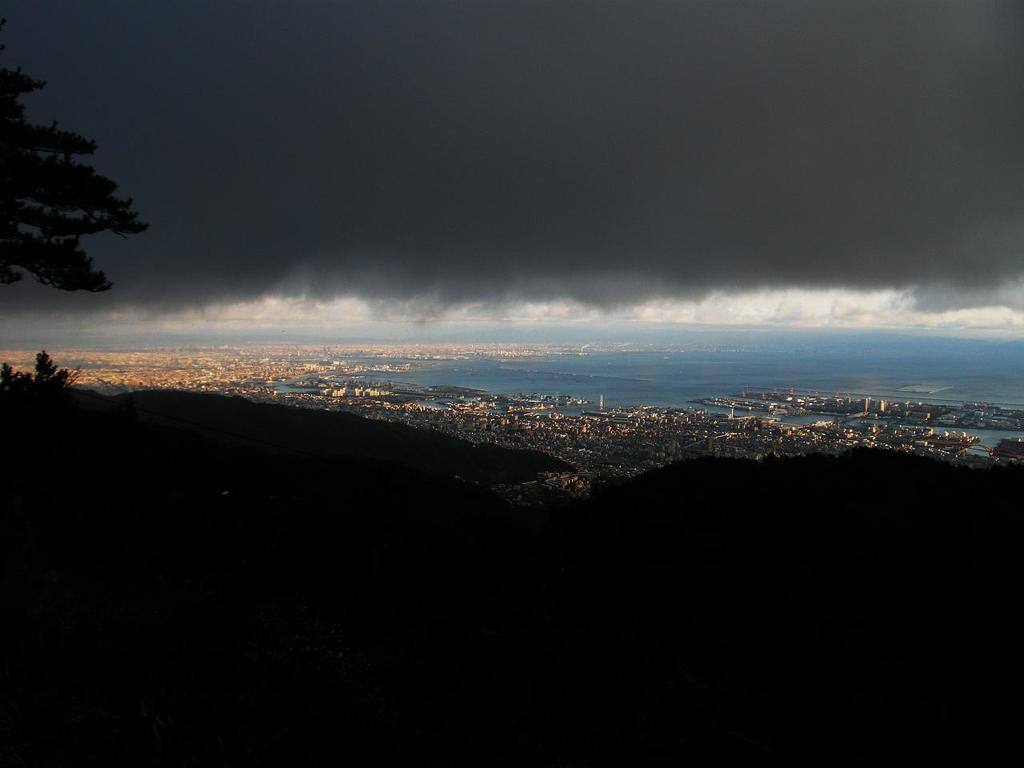What can be seen in the sky in the image? The sky is visible in the image, and clouds are present. What type of natural feature can be seen in the image? There is water visible in the image. What type of man-made structures are present in the image? Buildings are present in the image. What type of vertical structures are visible in the image? Poles are visible in the image. What type of vegetation is present in the image? Trees are present in the image. Can you describe any other objects in the image? There are a few other objects in the image, but their specific details are not mentioned in the provided facts. What type of underwear is visible on the trees in the image? There is no underwear present in the image, and underwear is not associated with trees. What type of skirt can be seen on the buildings in the image? There is no skirt present in the image, and skirts are not associated with buildings. 